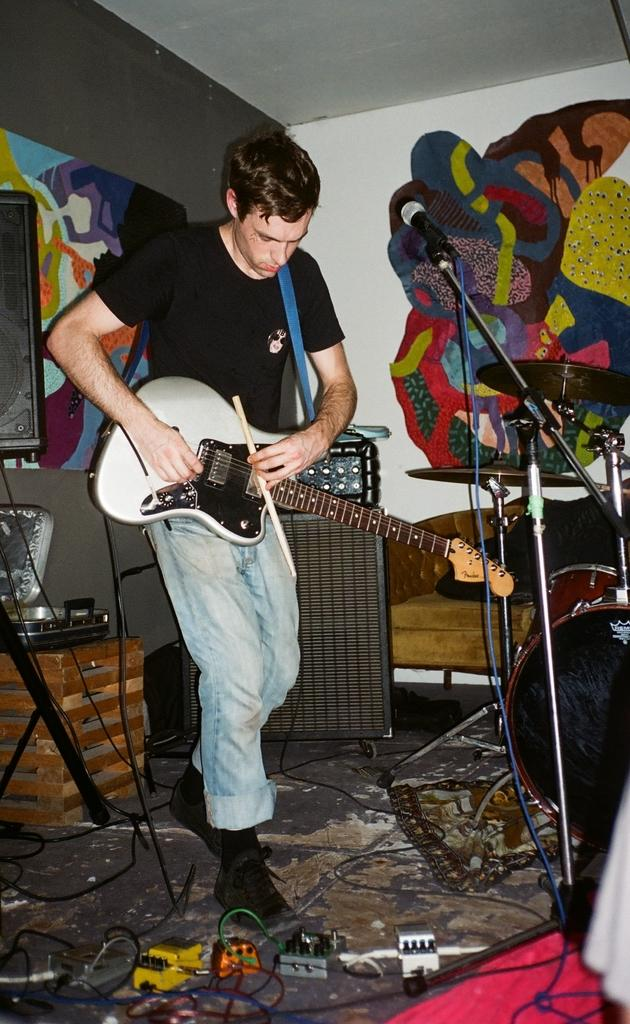What is the main subject of the image? The main subject of the image is a man. What is the man doing in the image? The man is standing in the image. What object is the man holding in his hand? The man is holding a guitar in his hand. What type of plants can be seen growing on the scale in the image? There is no scale or plants present in the image; it features a man standing and holding a guitar. 